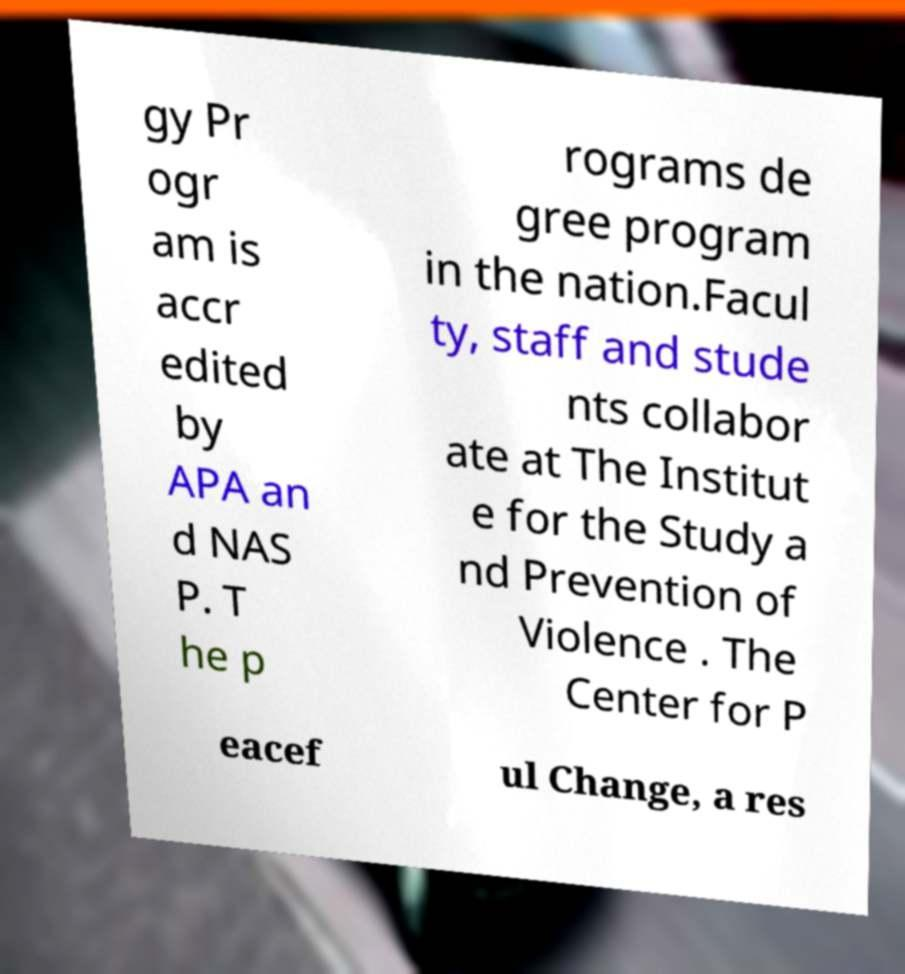Can you read and provide the text displayed in the image?This photo seems to have some interesting text. Can you extract and type it out for me? gy Pr ogr am is accr edited by APA an d NAS P. T he p rograms de gree program in the nation.Facul ty, staff and stude nts collabor ate at The Institut e for the Study a nd Prevention of Violence . The Center for P eacef ul Change, a res 